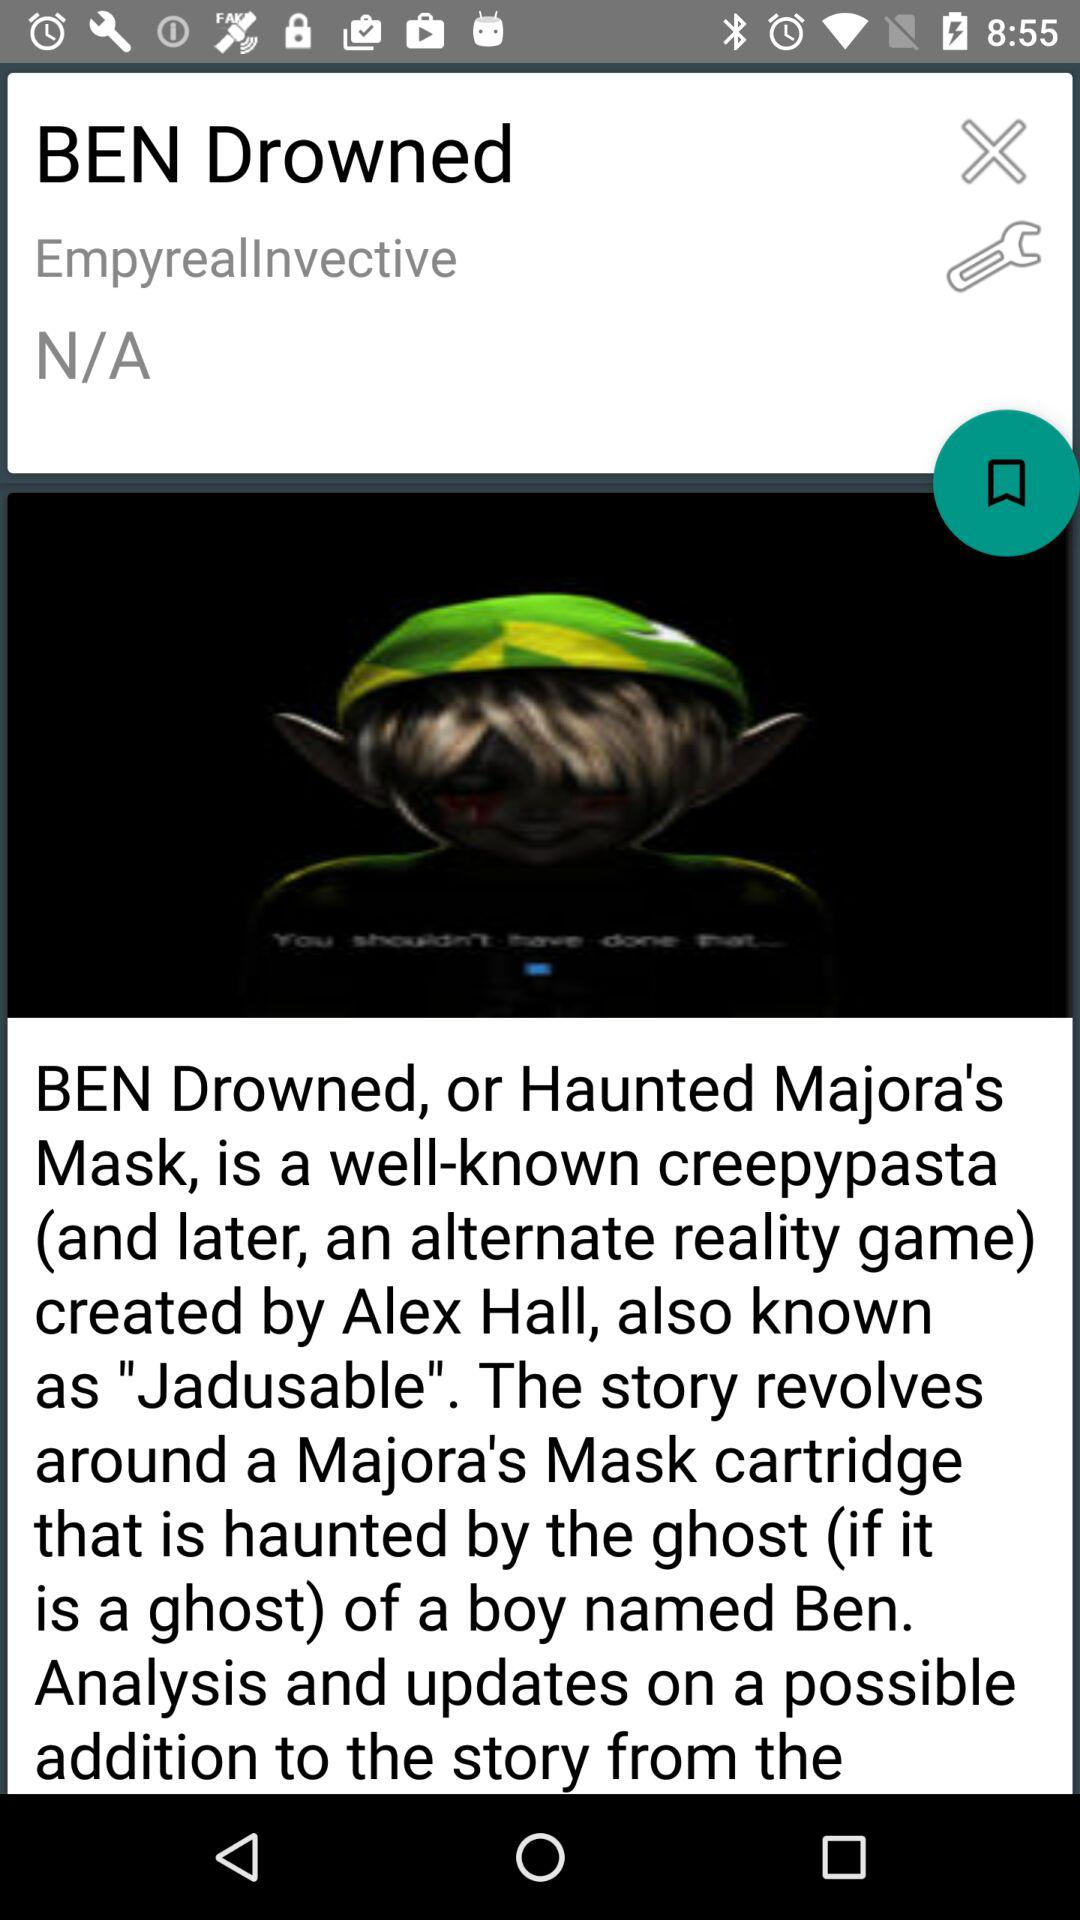What is the name of the game? The name of the game is "BEN Drowned". 